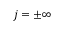Convert formula to latex. <formula><loc_0><loc_0><loc_500><loc_500>j = \pm \infty</formula> 